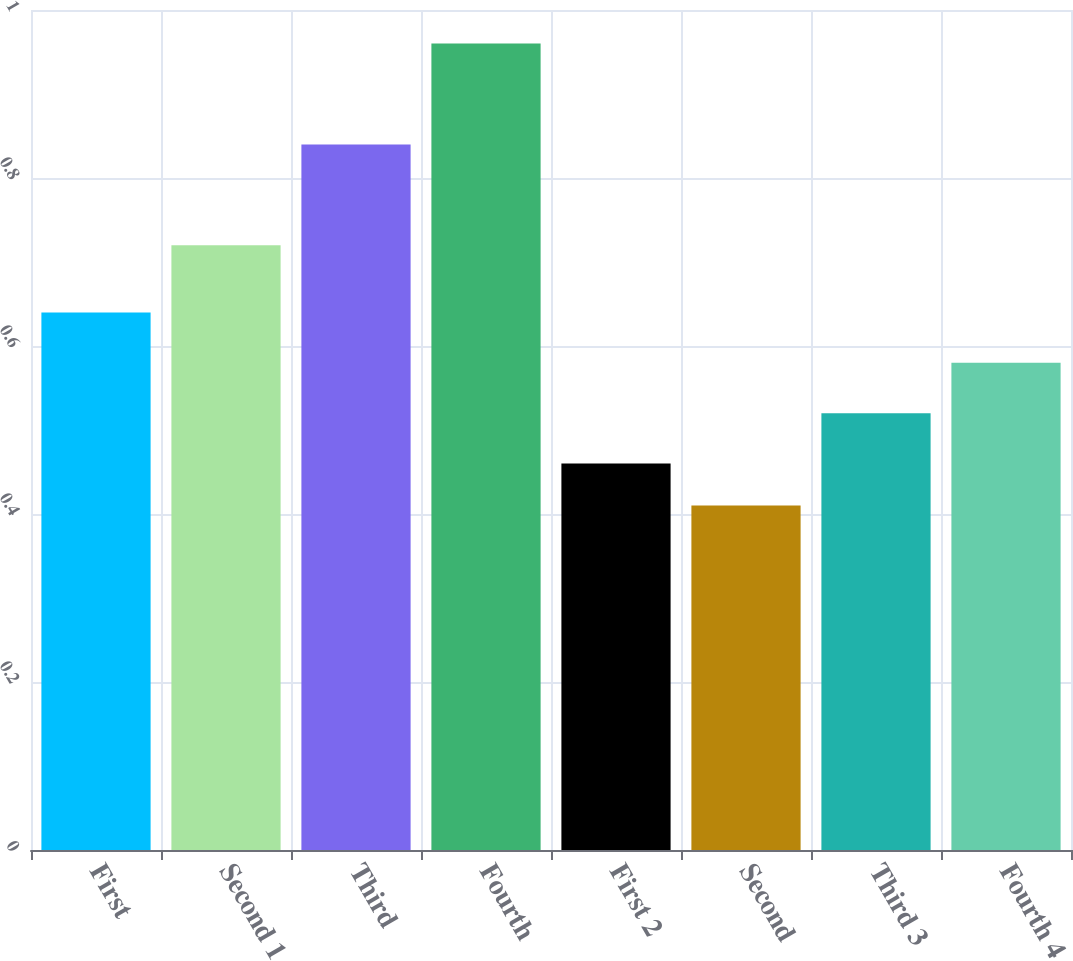Convert chart. <chart><loc_0><loc_0><loc_500><loc_500><bar_chart><fcel>First<fcel>Second 1<fcel>Third<fcel>Fourth<fcel>First 2<fcel>Second<fcel>Third 3<fcel>Fourth 4<nl><fcel>0.64<fcel>0.72<fcel>0.84<fcel>0.96<fcel>0.46<fcel>0.41<fcel>0.52<fcel>0.58<nl></chart> 